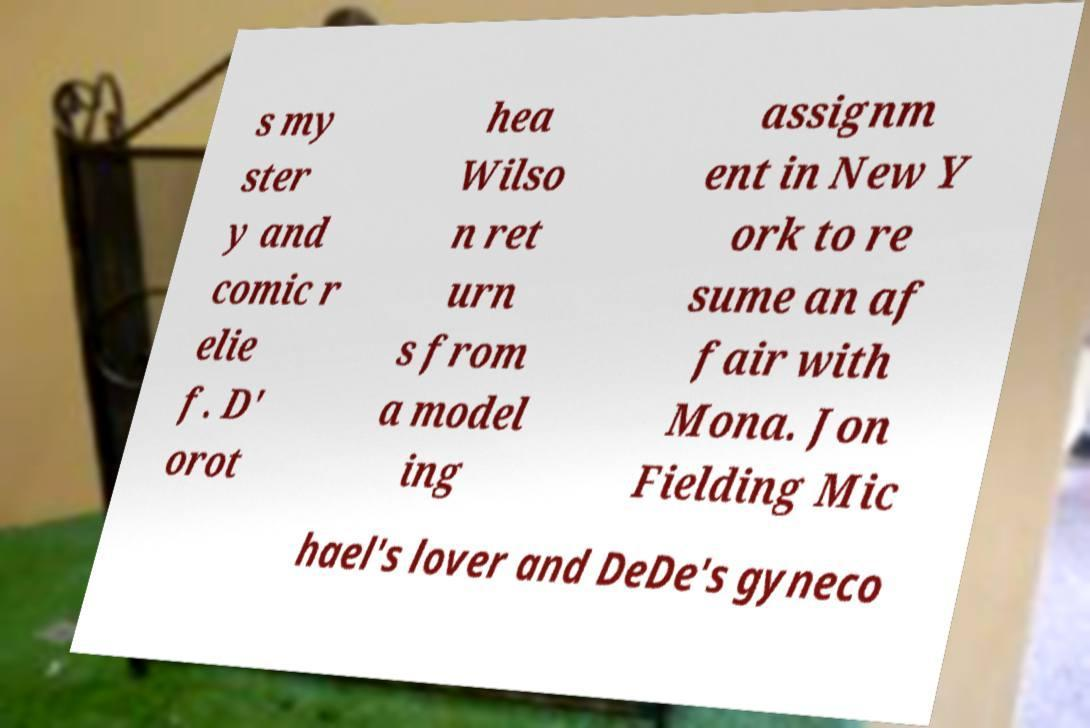Please identify and transcribe the text found in this image. s my ster y and comic r elie f. D' orot hea Wilso n ret urn s from a model ing assignm ent in New Y ork to re sume an af fair with Mona. Jon Fielding Mic hael's lover and DeDe's gyneco 